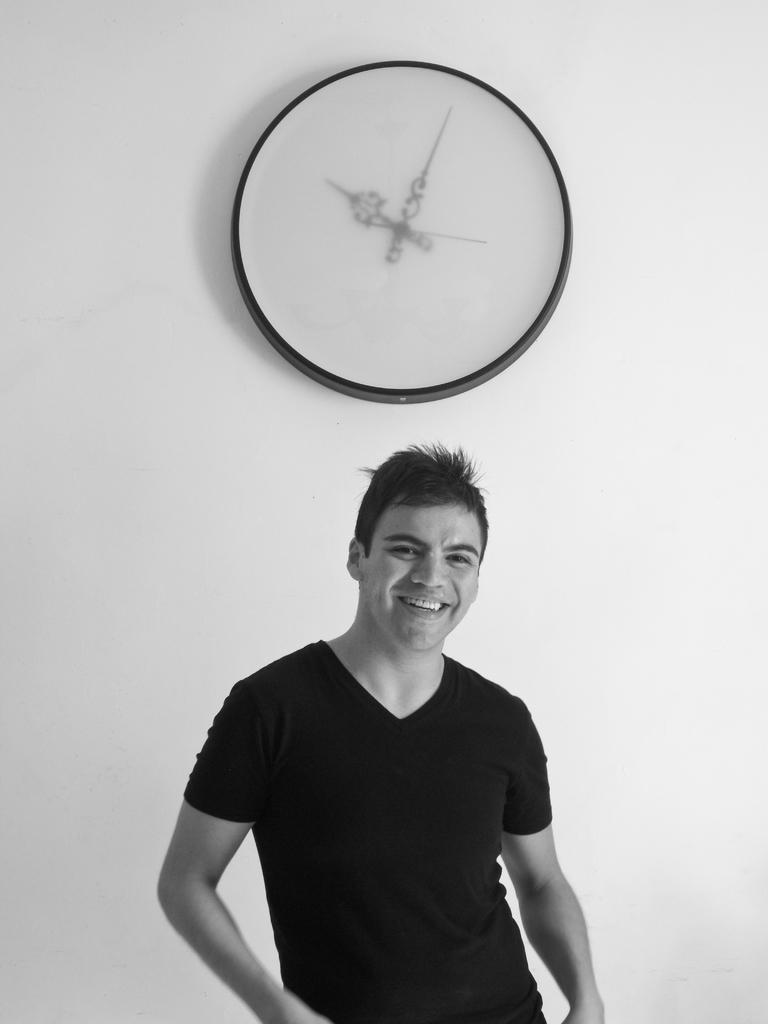Describe this image in one or two sentences. In this picture we can see a man, he is smiling, behind to him we can find a clock on the wall. 